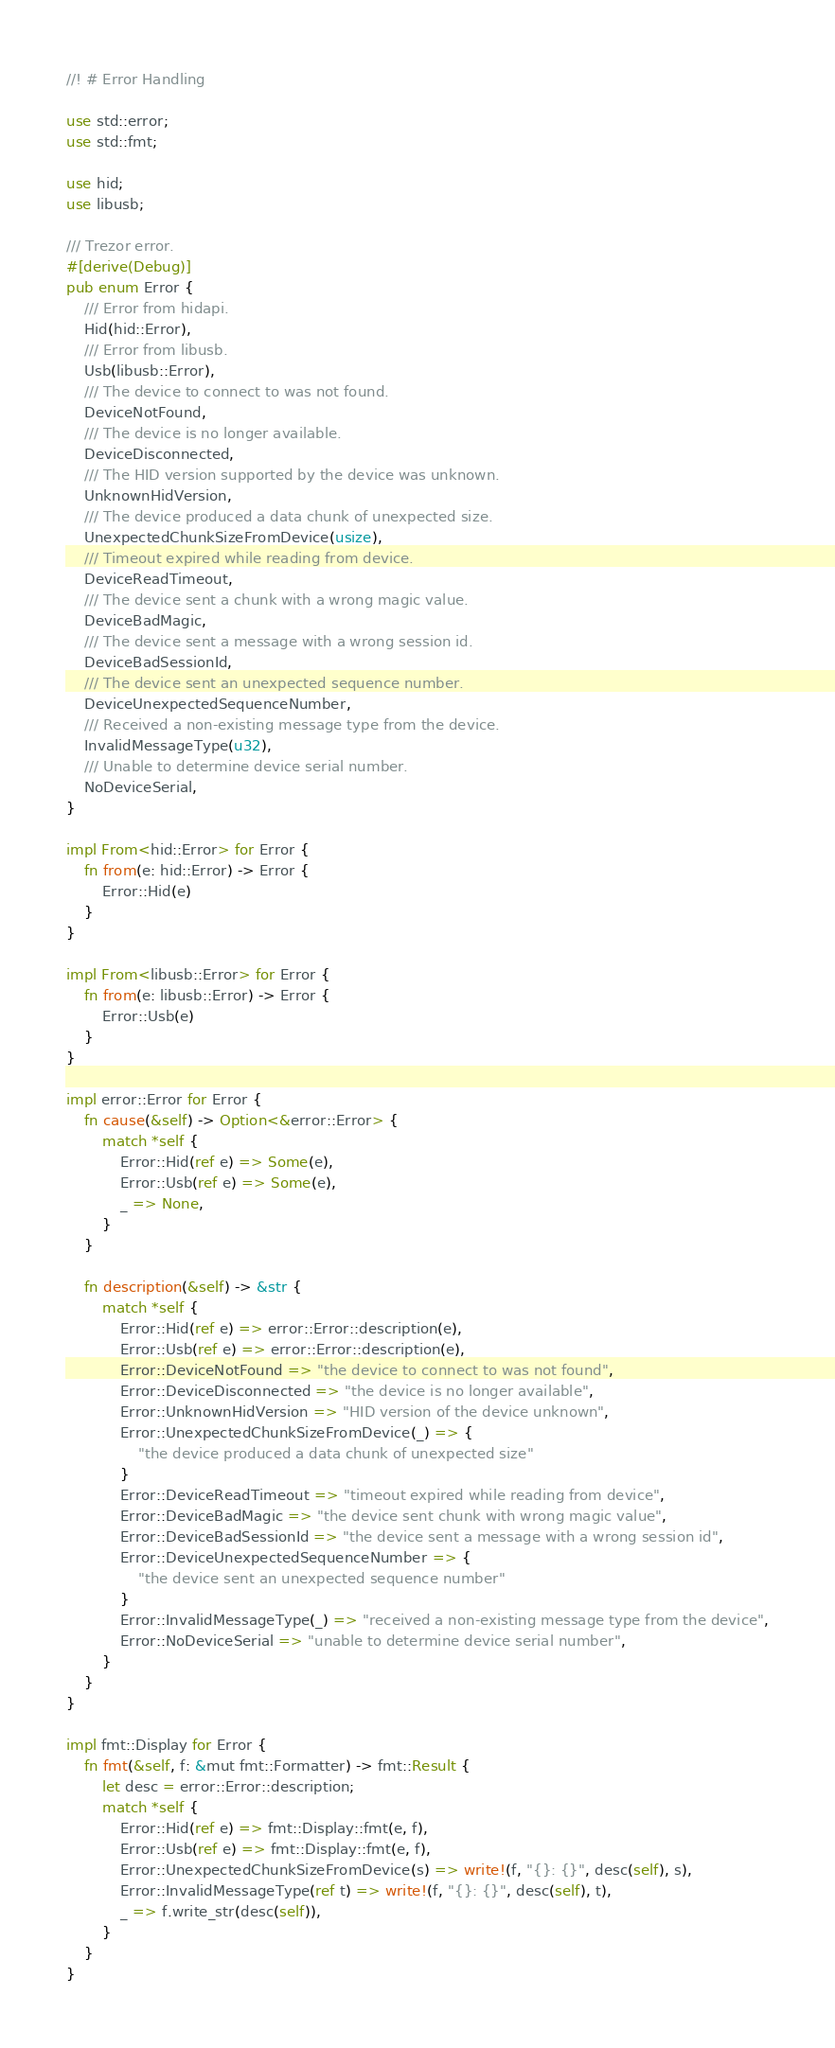<code> <loc_0><loc_0><loc_500><loc_500><_Rust_>//! # Error Handling

use std::error;
use std::fmt;

use hid;
use libusb;

/// Trezor error.
#[derive(Debug)]
pub enum Error {
	/// Error from hidapi.
	Hid(hid::Error),
	/// Error from libusb.
	Usb(libusb::Error),
	/// The device to connect to was not found.
	DeviceNotFound,
	/// The device is no longer available.
	DeviceDisconnected,
	/// The HID version supported by the device was unknown.
	UnknownHidVersion,
	/// The device produced a data chunk of unexpected size.
	UnexpectedChunkSizeFromDevice(usize),
	/// Timeout expired while reading from device.
	DeviceReadTimeout,
	/// The device sent a chunk with a wrong magic value.
	DeviceBadMagic,
	/// The device sent a message with a wrong session id.
	DeviceBadSessionId,
	/// The device sent an unexpected sequence number.
	DeviceUnexpectedSequenceNumber,
	/// Received a non-existing message type from the device.
	InvalidMessageType(u32),
	/// Unable to determine device serial number.
	NoDeviceSerial,
}

impl From<hid::Error> for Error {
	fn from(e: hid::Error) -> Error {
		Error::Hid(e)
	}
}

impl From<libusb::Error> for Error {
	fn from(e: libusb::Error) -> Error {
		Error::Usb(e)
	}
}

impl error::Error for Error {
	fn cause(&self) -> Option<&error::Error> {
		match *self {
			Error::Hid(ref e) => Some(e),
			Error::Usb(ref e) => Some(e),
			_ => None,
		}
	}

	fn description(&self) -> &str {
		match *self {
			Error::Hid(ref e) => error::Error::description(e),
			Error::Usb(ref e) => error::Error::description(e),
			Error::DeviceNotFound => "the device to connect to was not found",
			Error::DeviceDisconnected => "the device is no longer available",
			Error::UnknownHidVersion => "HID version of the device unknown",
			Error::UnexpectedChunkSizeFromDevice(_) => {
				"the device produced a data chunk of unexpected size"
			}
			Error::DeviceReadTimeout => "timeout expired while reading from device",
			Error::DeviceBadMagic => "the device sent chunk with wrong magic value",
			Error::DeviceBadSessionId => "the device sent a message with a wrong session id",
			Error::DeviceUnexpectedSequenceNumber => {
				"the device sent an unexpected sequence number"
			}
			Error::InvalidMessageType(_) => "received a non-existing message type from the device",
			Error::NoDeviceSerial => "unable to determine device serial number",
		}
	}
}

impl fmt::Display for Error {
	fn fmt(&self, f: &mut fmt::Formatter) -> fmt::Result {
		let desc = error::Error::description;
		match *self {
			Error::Hid(ref e) => fmt::Display::fmt(e, f),
			Error::Usb(ref e) => fmt::Display::fmt(e, f),
			Error::UnexpectedChunkSizeFromDevice(s) => write!(f, "{}: {}", desc(self), s),
			Error::InvalidMessageType(ref t) => write!(f, "{}: {}", desc(self), t),
			_ => f.write_str(desc(self)),
		}
	}
}
</code> 